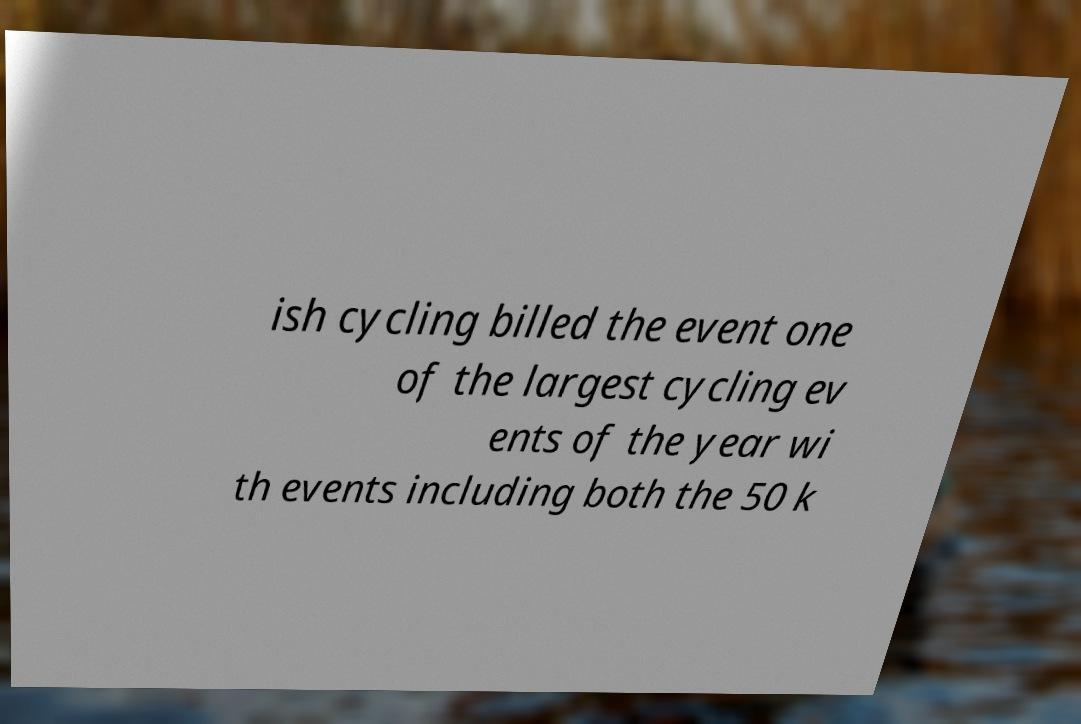Could you assist in decoding the text presented in this image and type it out clearly? ish cycling billed the event one of the largest cycling ev ents of the year wi th events including both the 50 k 